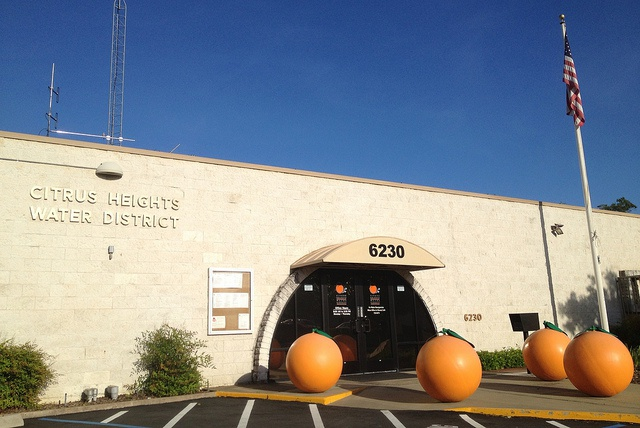Describe the objects in this image and their specific colors. I can see orange in blue, orange, brown, and maroon tones, orange in blue, maroon, and orange tones, orange in blue, orange, and brown tones, orange in blue, maroon, brown, and orange tones, and orange in blue, black, maroon, and brown tones in this image. 